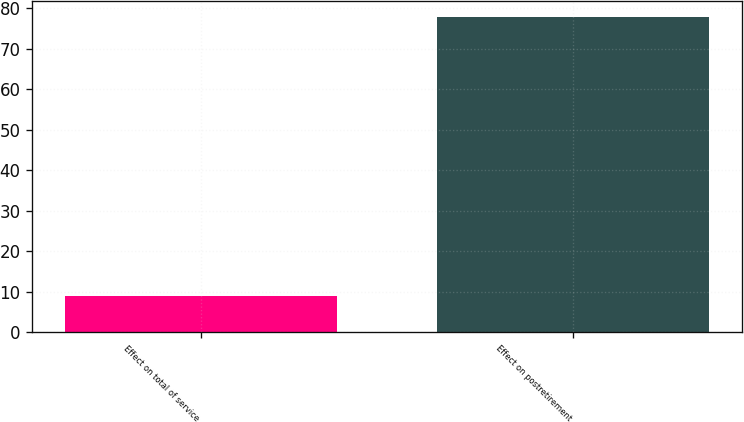Convert chart. <chart><loc_0><loc_0><loc_500><loc_500><bar_chart><fcel>Effect on total of service<fcel>Effect on postretirement<nl><fcel>9<fcel>78<nl></chart> 